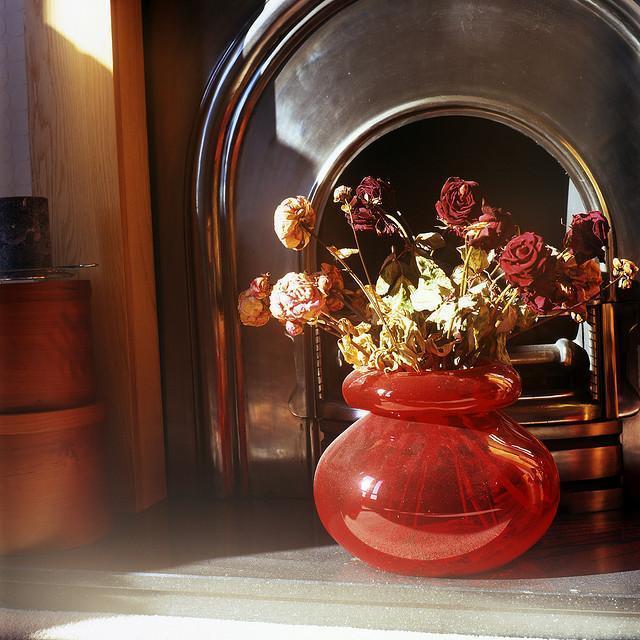How many people can be seen?
Give a very brief answer. 0. 